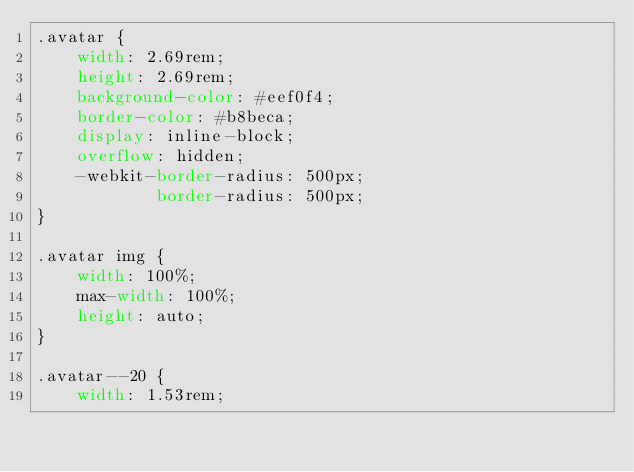<code> <loc_0><loc_0><loc_500><loc_500><_CSS_>.avatar {
    width: 2.69rem;
    height: 2.69rem;
    background-color: #eef0f4;
    border-color: #b8beca;
    display: inline-block;
    overflow: hidden;
    -webkit-border-radius: 500px;
            border-radius: 500px;
}

.avatar img {
    width: 100%;
    max-width: 100%;
    height: auto;
}

.avatar--20 {
    width: 1.53rem;</code> 